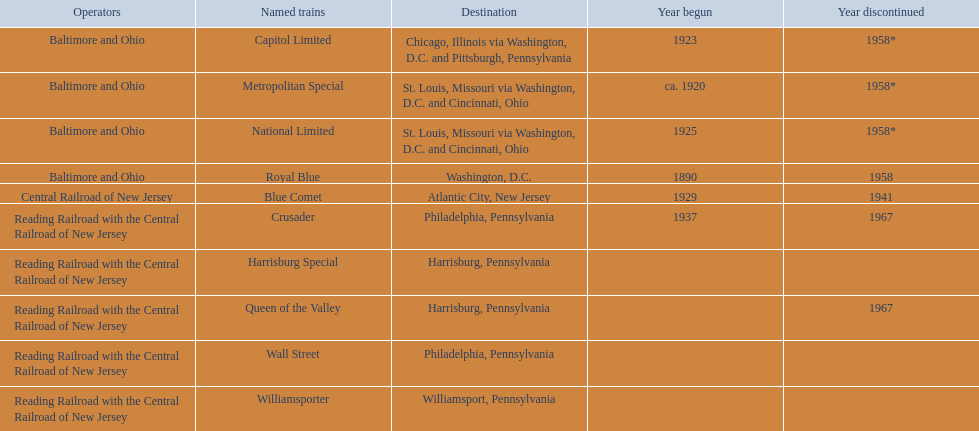Which operators connect the reading railroad with the central railroad of new jersey? Reading Railroad with the Central Railroad of New Jersey, Reading Railroad with the Central Railroad of New Jersey, Reading Railroad with the Central Railroad of New Jersey, Reading Railroad with the Central Railroad of New Jersey, Reading Railroad with the Central Railroad of New Jersey. Which places are philadelphia, pennsylvania? Philadelphia, Pennsylvania, Philadelphia, Pennsylvania. Parse the table in full. {'header': ['Operators', 'Named trains', 'Destination', 'Year begun', 'Year discontinued'], 'rows': [['Baltimore and Ohio', 'Capitol Limited', 'Chicago, Illinois via Washington, D.C. and Pittsburgh, Pennsylvania', '1923', '1958*'], ['Baltimore and Ohio', 'Metropolitan Special', 'St. Louis, Missouri via Washington, D.C. and Cincinnati, Ohio', 'ca. 1920', '1958*'], ['Baltimore and Ohio', 'National Limited', 'St. Louis, Missouri via Washington, D.C. and Cincinnati, Ohio', '1925', '1958*'], ['Baltimore and Ohio', 'Royal Blue', 'Washington, D.C.', '1890', '1958'], ['Central Railroad of New Jersey', 'Blue Comet', 'Atlantic City, New Jersey', '1929', '1941'], ['Reading Railroad with the Central Railroad of New Jersey', 'Crusader', 'Philadelphia, Pennsylvania', '1937', '1967'], ['Reading Railroad with the Central Railroad of New Jersey', 'Harrisburg Special', 'Harrisburg, Pennsylvania', '', ''], ['Reading Railroad with the Central Railroad of New Jersey', 'Queen of the Valley', 'Harrisburg, Pennsylvania', '', '1967'], ['Reading Railroad with the Central Railroad of New Jersey', 'Wall Street', 'Philadelphia, Pennsylvania', '', ''], ['Reading Railroad with the Central Railroad of New Jersey', 'Williamsporter', 'Williamsport, Pennsylvania', '', '']]} What commenced in 1937? 1937. What is the named train? Crusader. 